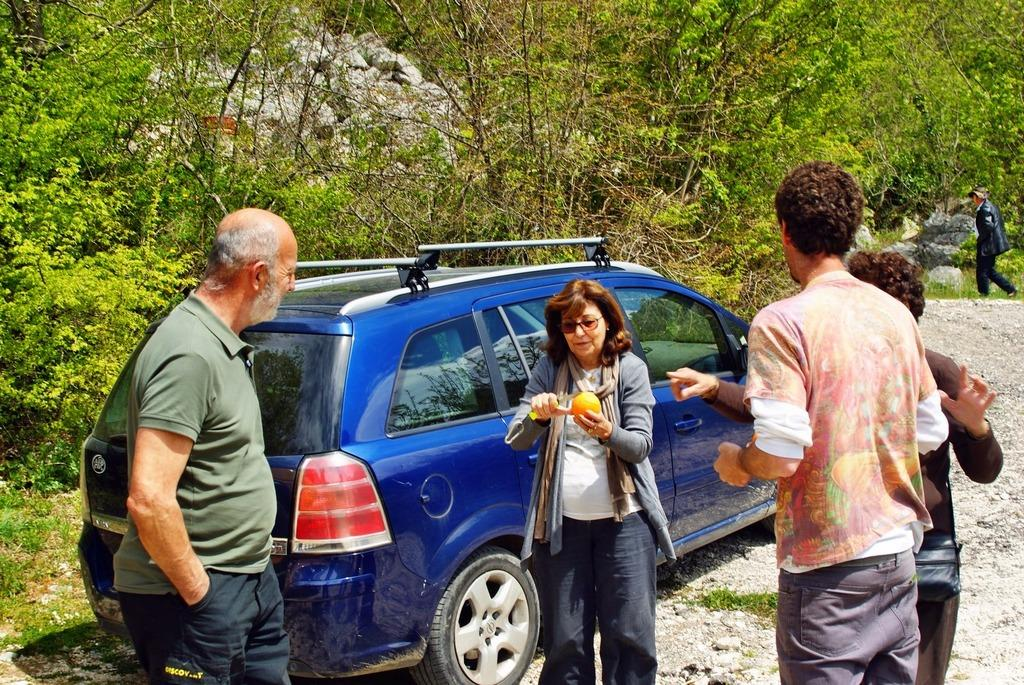Who or what can be seen in the image? There are people in the image. What type of natural elements are present in the image? There are trees, plants, and stones in the image. What is the surface on which the people and objects are situated? The ground is visible in the image. What type of man-made object is present in the image? There is a vehicle in the image. How many ants can be seen carrying credit cards in the image? There are no ants or credit cards present in the image. What type of slave is depicted in the image? There is no depiction of a slave in the image; it features people, trees, plants, stones, the ground, and a vehicle. 